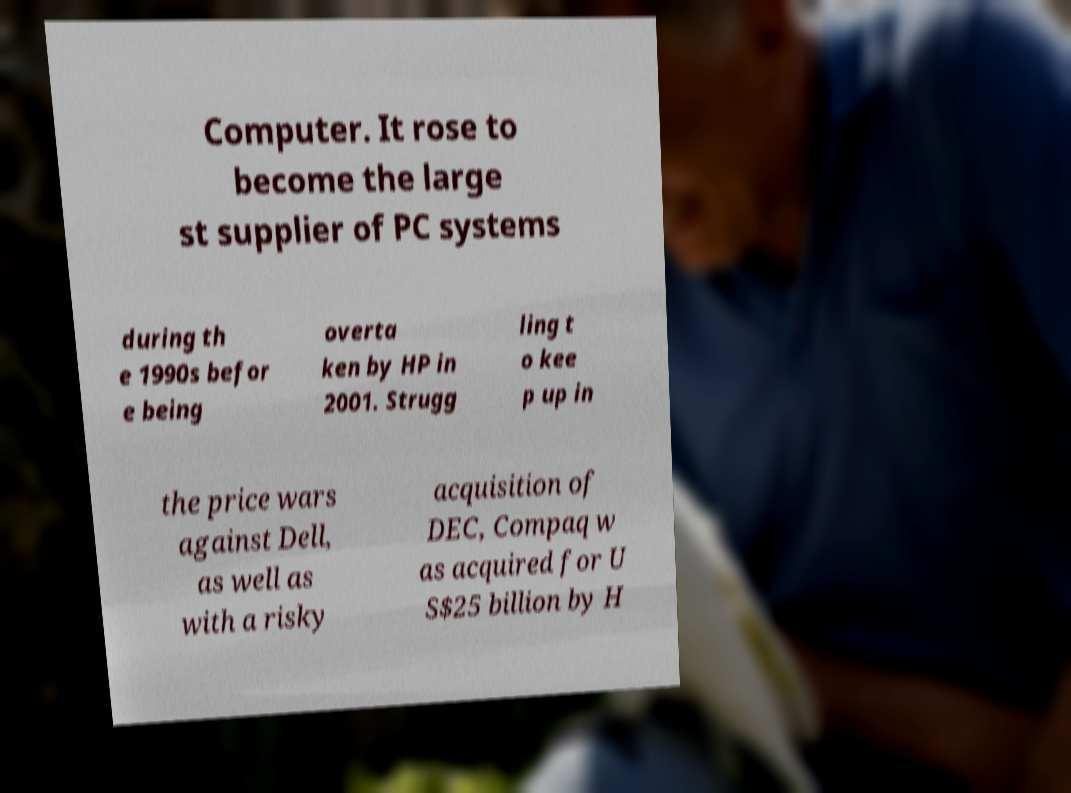Please read and relay the text visible in this image. What does it say? Computer. It rose to become the large st supplier of PC systems during th e 1990s befor e being overta ken by HP in 2001. Strugg ling t o kee p up in the price wars against Dell, as well as with a risky acquisition of DEC, Compaq w as acquired for U S$25 billion by H 